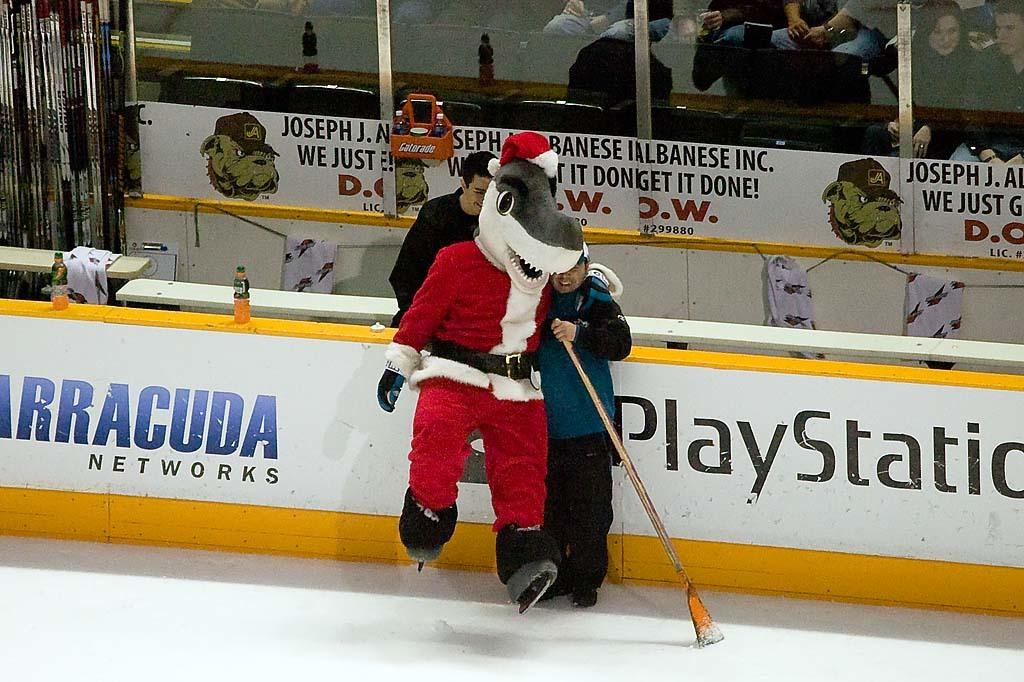Provide a one-sentence caption for the provided image. Santa Claus wearing a shark mask on a hockey field near a Playstation ad. 